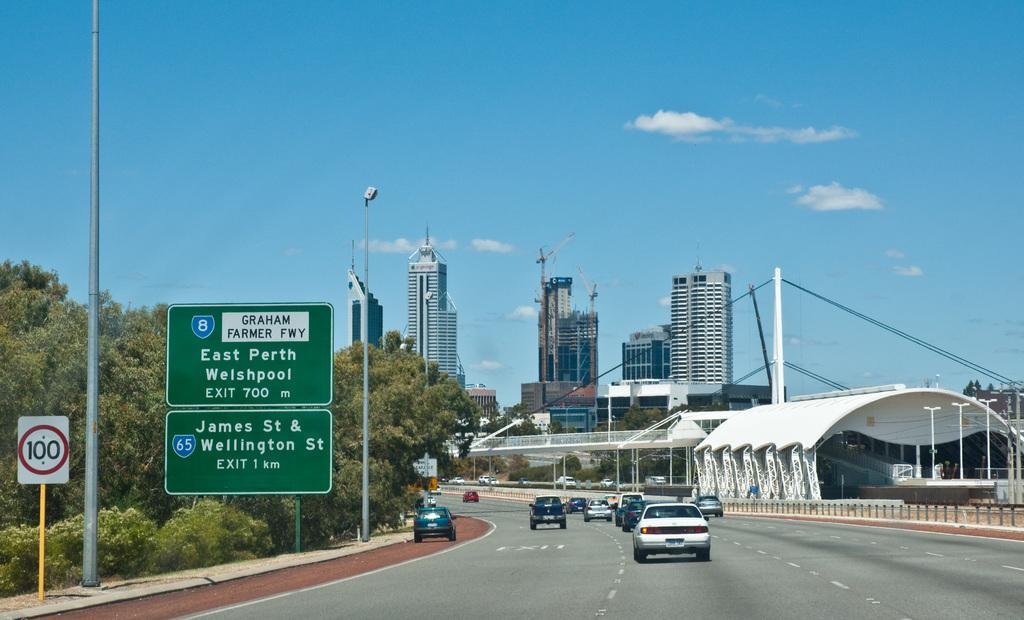<image>
Share a concise interpretation of the image provided. A highway outside a city with exits for East Perth and Welshpool. 